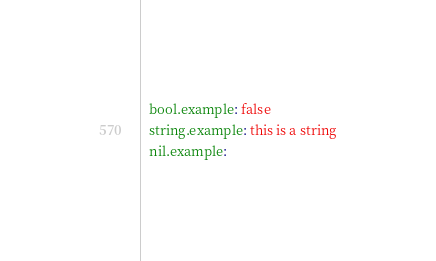<code> <loc_0><loc_0><loc_500><loc_500><_YAML_>  bool.example: false
  string.example: this is a string
  nil.example:
</code> 